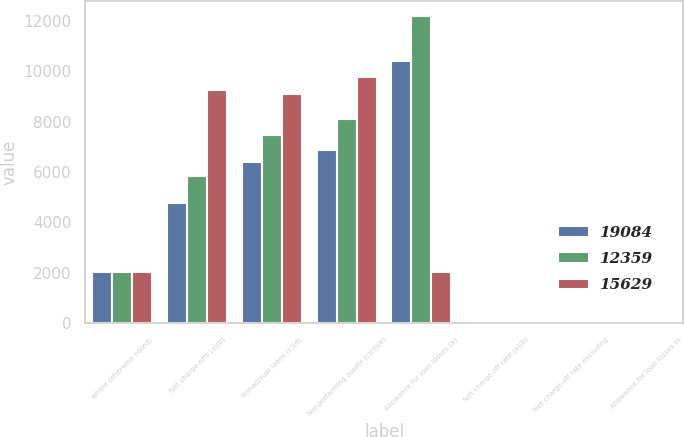Convert chart. <chart><loc_0><loc_0><loc_500><loc_500><stacked_bar_chart><ecel><fcel>where otherwise noted)<fcel>Net charge-offs (a)(b)<fcel>Nonaccrual loans (c)(d)<fcel>Nonperforming assets (c)(d)(e)<fcel>Allowance for loan losses (a)<fcel>Net charge-off rate (a)(b)<fcel>Net charge-off rate excluding<fcel>Allowance for loan losses to<nl><fcel>19084<fcel>2014<fcel>4773<fcel>6401<fcel>6872<fcel>10404<fcel>1.22<fcel>1.4<fcel>2.63<nl><fcel>12359<fcel>2013<fcel>5826<fcel>7455<fcel>8109<fcel>12201<fcel>1.48<fcel>1.73<fcel>3.1<nl><fcel>15629<fcel>2012<fcel>9280<fcel>9114<fcel>9791<fcel>2014<fcel>2.27<fcel>2.68<fcel>4.41<nl></chart> 